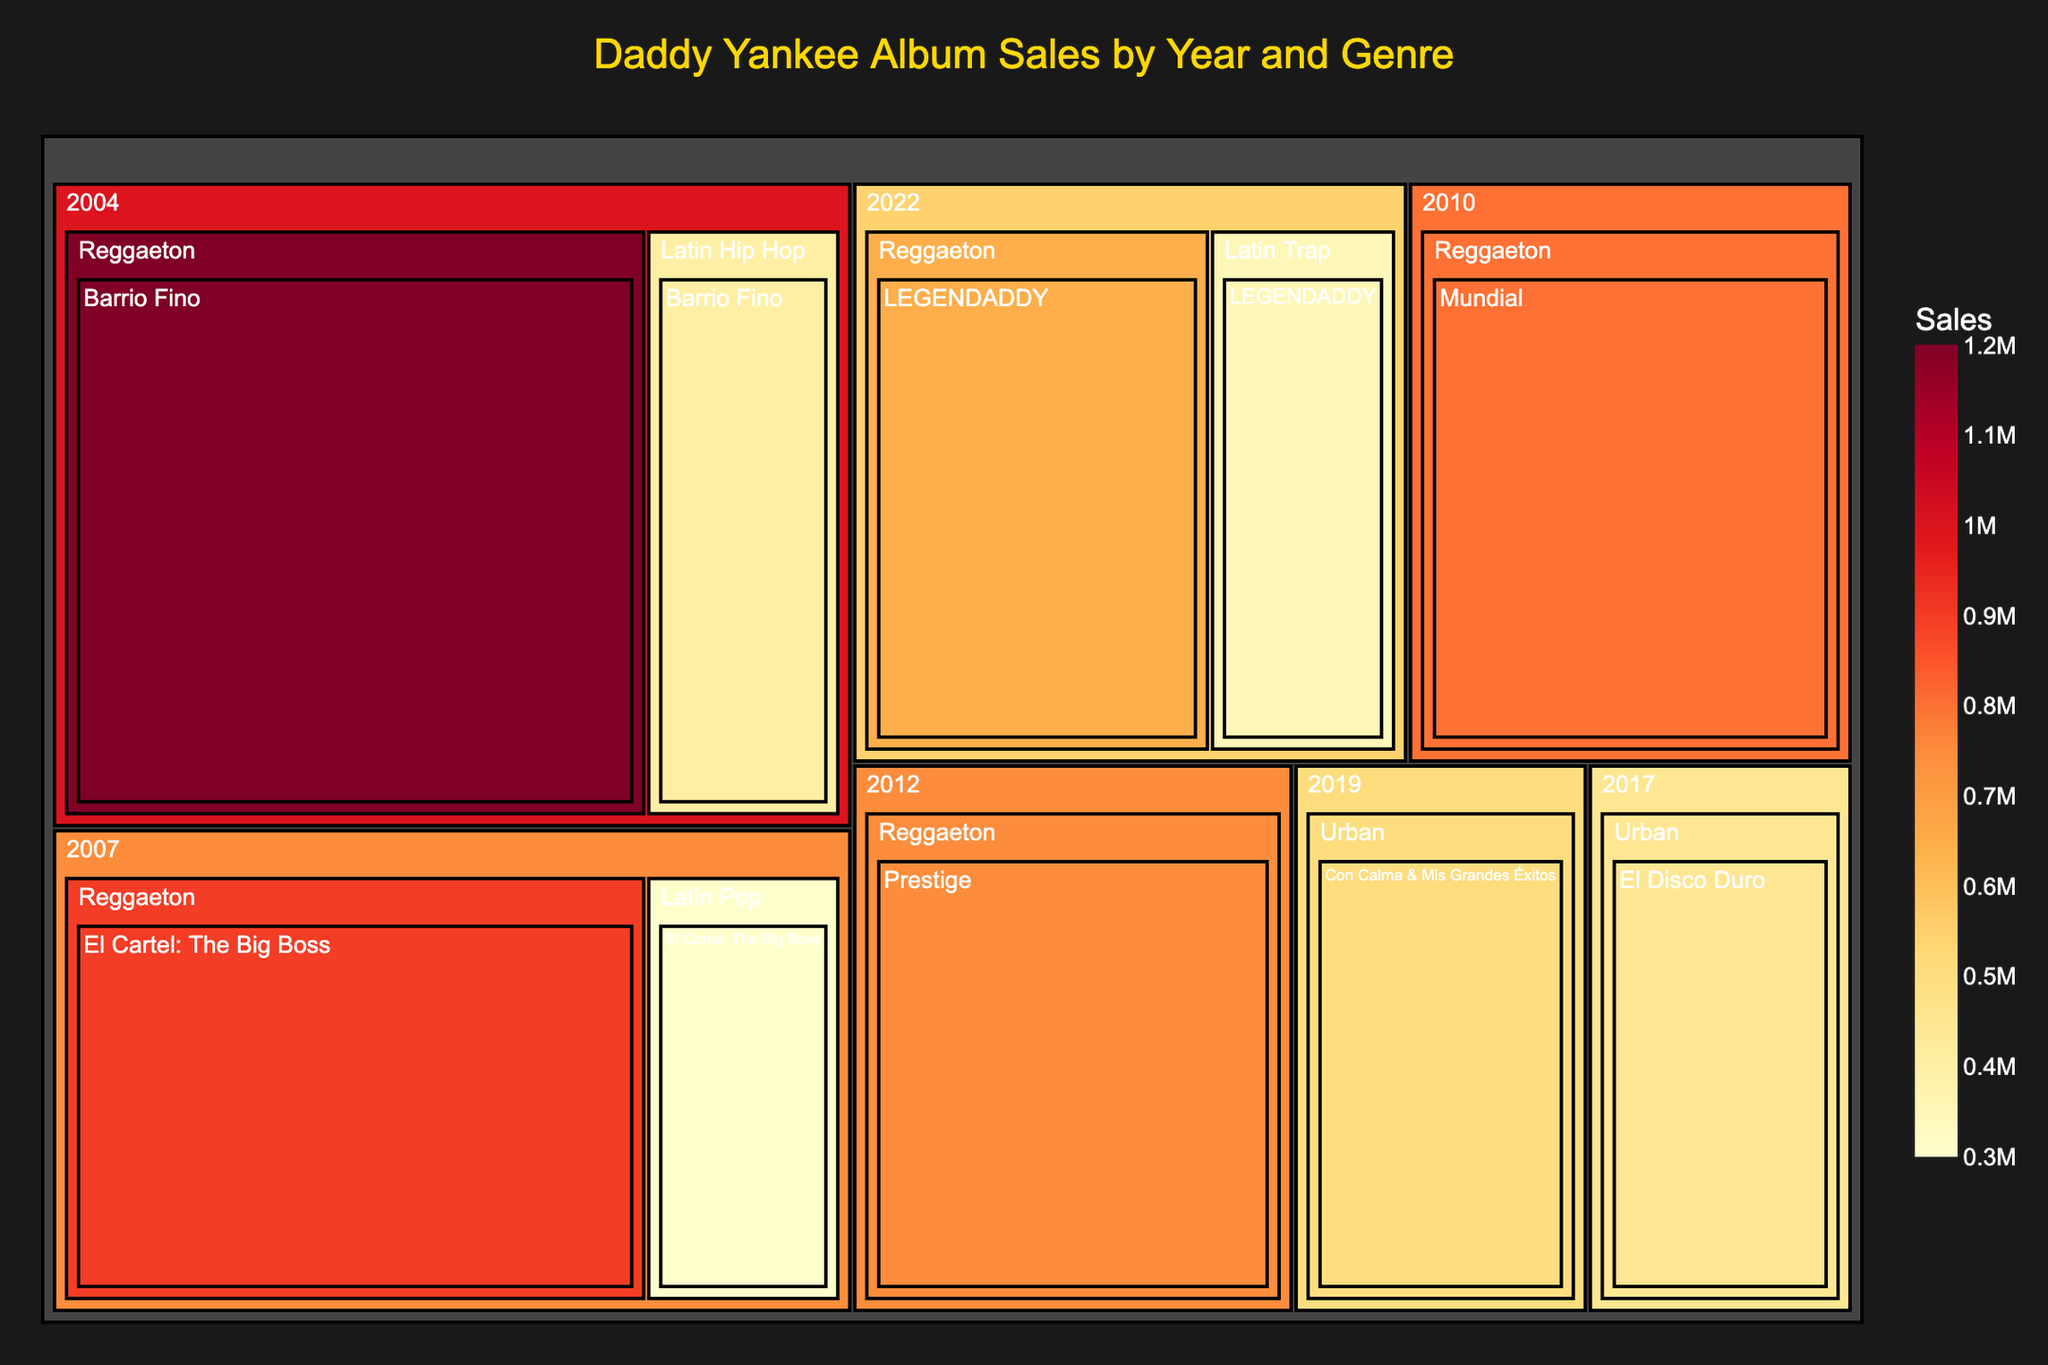What is the title of the Treemap? The title of the Treemap is displayed at the top of the figure and provides context about what the visualization represents.
Answer: Daddy Yankee Album Sales by Year and Genre Which album has the highest sales according to the Treemap? Identify the album with the largest area in the Treemap since the size corresponds to the sales value. Barrio Fino in the Reggaeton genre of 2004 has the largest area.
Answer: Barrio Fino How many albums are represented for the year 2007? Look at the year 2007 section and count the number of individual album segments within that year. There are two albums: El Cartel: The Big Boss in Reggaeton and Latin Pop.
Answer: 2 What is the total sales for the year 2022? Sum the sales figures for all the albums under the year 2022. There are two albums: LEGENDADDY in Reggaeton (650,000) and LEGENDADDY in Latin Trap (350,000). So, 650,000 + 350,000 = 1,000,000.
Answer: 1,000,000 Which genre has the highest overall sales? Sum the sales for each genre and compare. Reggaeton has the highest overall sales. For this genre, sum the sales of Barrio Fino (1,200,000), El Cartel (900,000), Prestige (750,000), Mundial (800,000), and LEGENDADDY (650,000). The total is 4,300,000.
Answer: Reggaeton Compare the sales of the albums released in 2004 across different genres. Which genre has more sales? Compare the sum of sales for the two albums from 2004: Barrio Fino in Reggaeton (1,200,000) vs. Barrio Fino in Latin Hip Hop (400,000). Reggaeton has more sales.
Answer: Reggaeton What is the average sales figure for all albums released in 2007? Add the sales figures for El Cartel in Reggaeton (900,000) and Latin Pop (300,000), then divide by the number of albums. (900,000 + 300,000) / 2 = 600,000.
Answer: 600,000 Which year has the lowest total album sales? Compare the total sales summed up year by year. The year with the lowest total sum is 2019 with just one album Con Calma & Mis Grandes Éxitos having 500,000 in sales.
Answer: 2019 How do the sales of the 2017 album compare to the 2019 album? Compare the sales values of El Disco Duro in 2017 (450,000) with Con Calma & Mis Grandes Éxitos in 2019 (500,000). Since 450,000 < 500,000, the 2017 album has lower sales than the 2019 album.
Answer: The 2017 album has lower sales Which genre had more sales in 2022, Reggaeton or Latin Trap? Compare the sales of LEGENDADDY in Reggaeton (650,000) with LEGENDADDY in Latin Trap (350,000). Reggaeton (650,000) has more sales than Latin Trap (350,000).
Answer: Reggaeton 